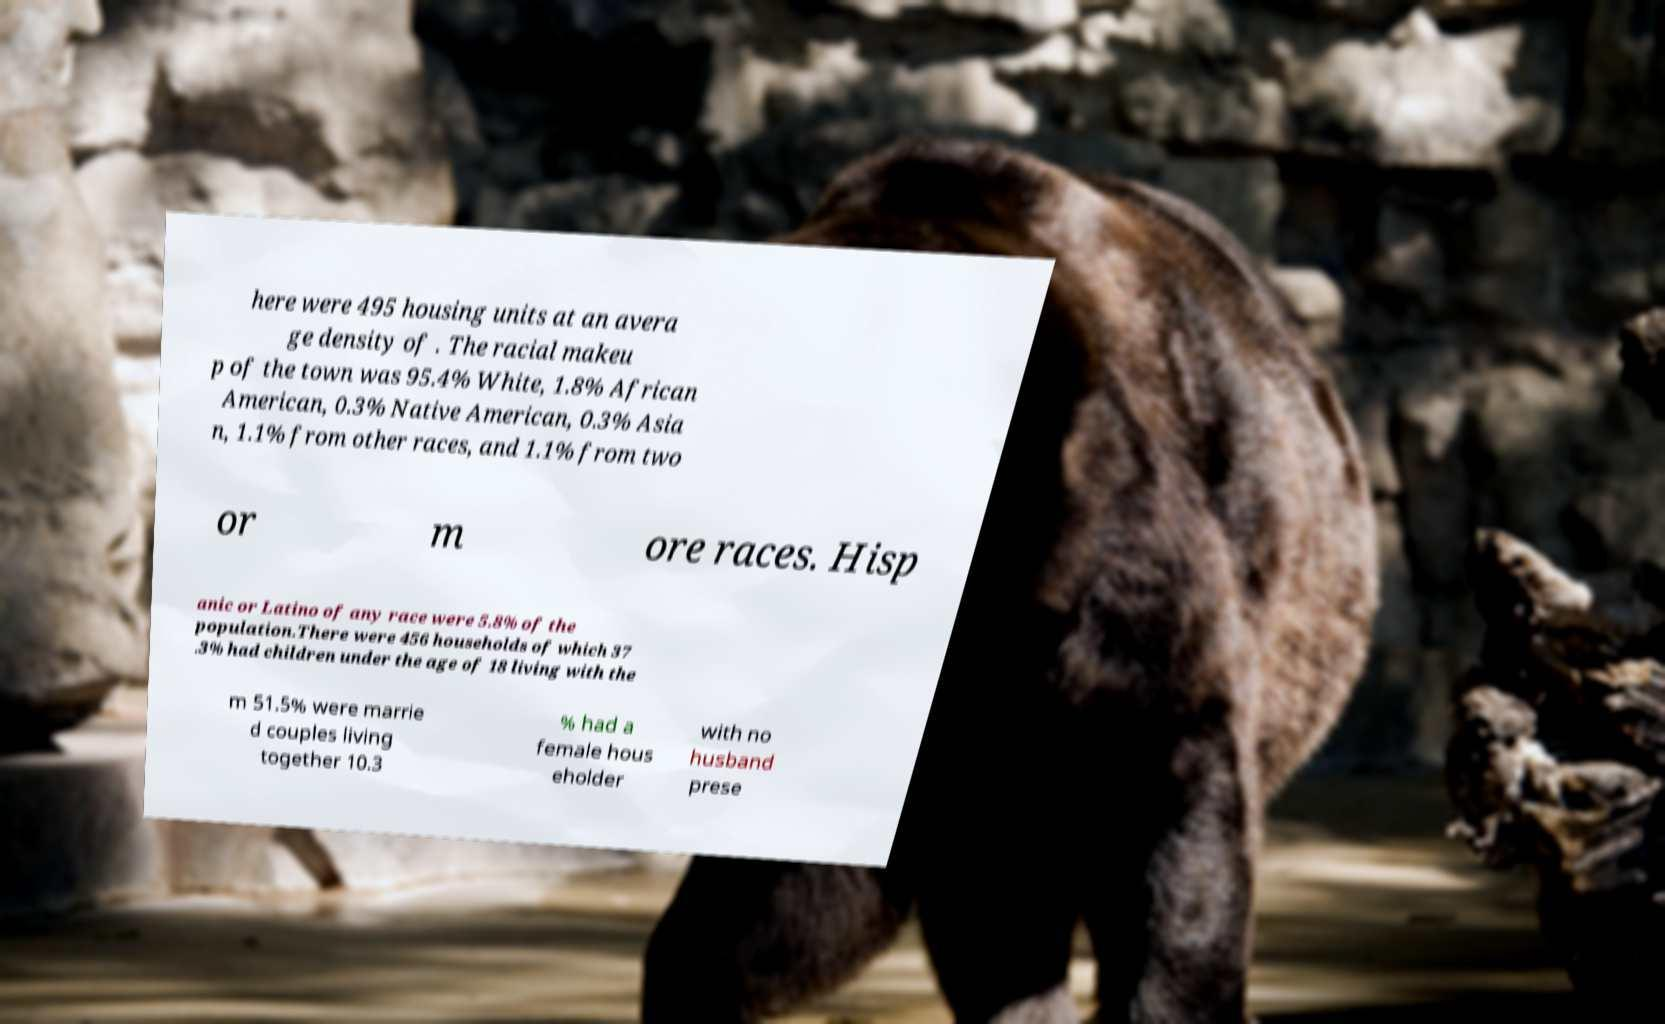Could you extract and type out the text from this image? here were 495 housing units at an avera ge density of . The racial makeu p of the town was 95.4% White, 1.8% African American, 0.3% Native American, 0.3% Asia n, 1.1% from other races, and 1.1% from two or m ore races. Hisp anic or Latino of any race were 5.8% of the population.There were 456 households of which 37 .3% had children under the age of 18 living with the m 51.5% were marrie d couples living together 10.3 % had a female hous eholder with no husband prese 